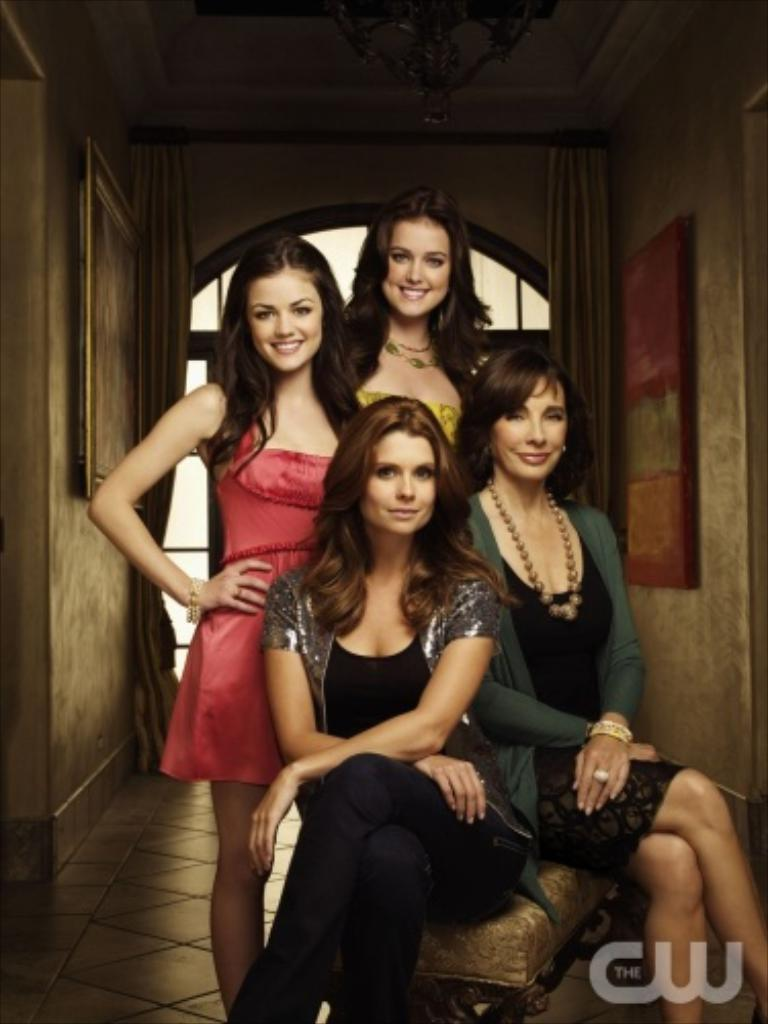Who or what can be seen in the image? There are people in the image. What is on the wall in the image? There are objects on the wall in the image. Where is the scene taking place? The image shows the inside of a house. What type of airplane can be seen flying through the house in the image? There is no airplane present in the image; it shows the inside of a house. 